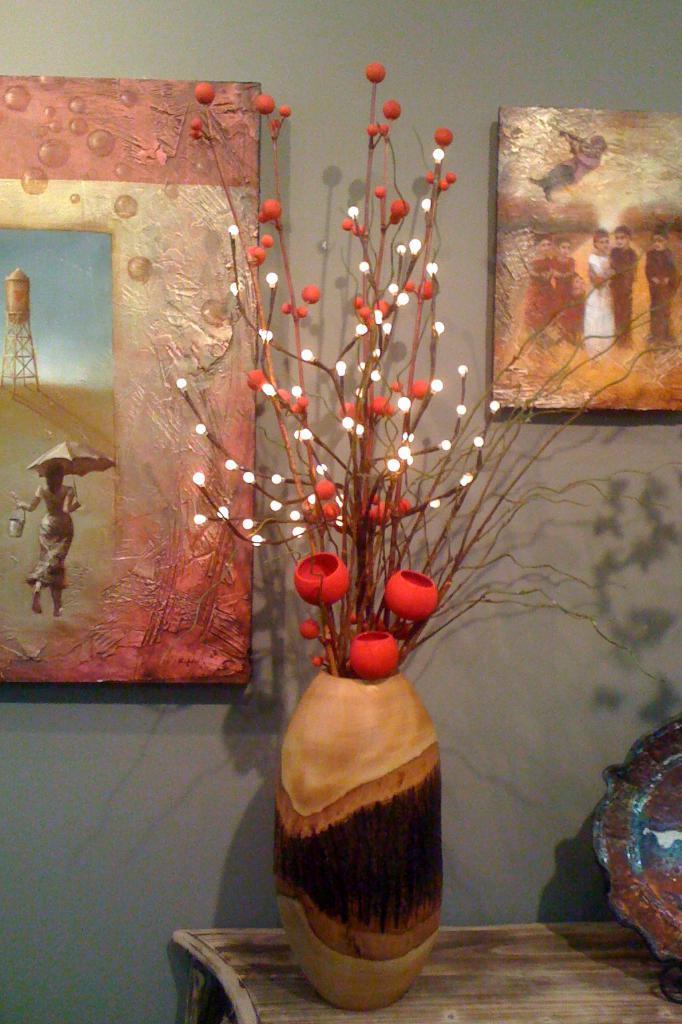How would you summarize this image in a sentence or two? In this image there is one flower vase is on a table as we can see in the bottom of this image. There is a wall in the background. There are some photo frames are attached on this wall. There is one object kept on to this table in the bottom left corner of this image. 